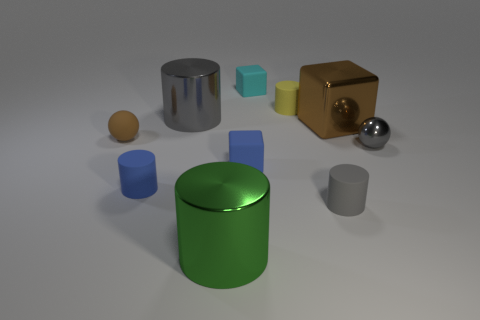If we were to arrange these objects by height, which one would be the tallest? If arranged by height, the tallest object would be the large gray cylinder, followed by the green cylinder, the golden cube, and so forth. The large gray cylinder's height appears to surpass all other objects in the immediate vicinity. 